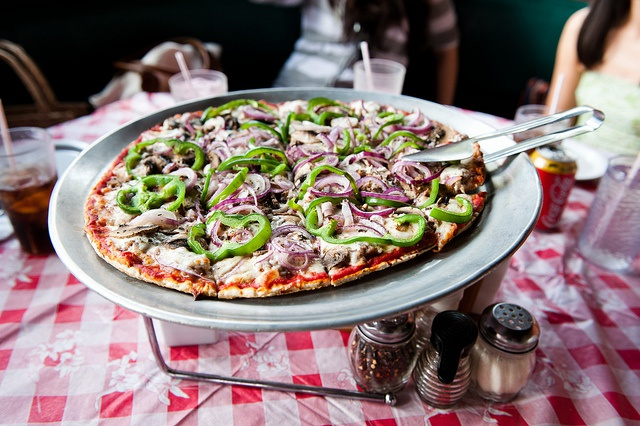Describe the objects in this image and their specific colors. I can see pizza in black, lightgray, pink, and darkgray tones, people in black, darkgray, gray, and lavender tones, people in black, ivory, and tan tones, cup in black, darkgray, and maroon tones, and cup in black, darkgray, gray, and lightgray tones in this image. 